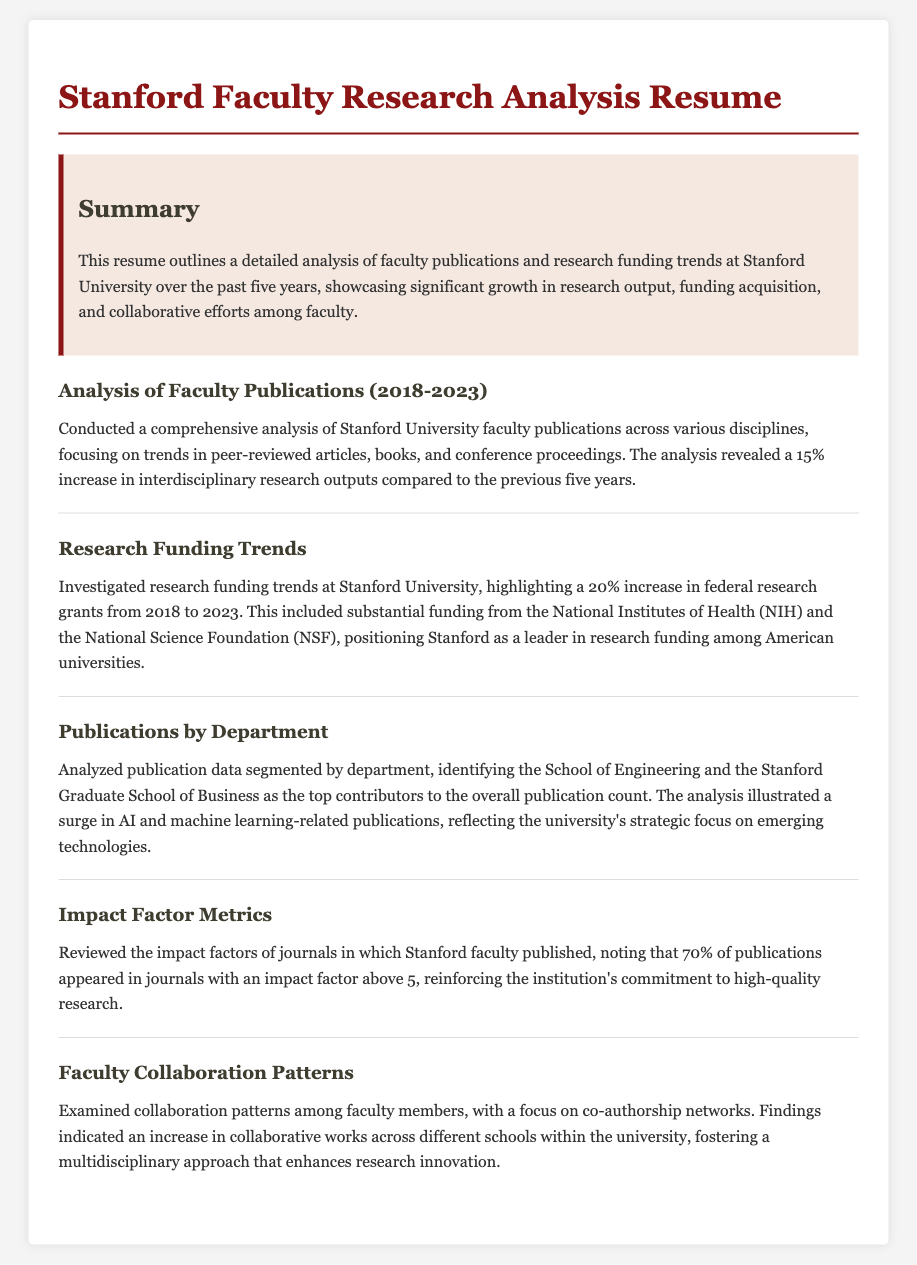What is the increase in interdisciplinary research outputs? The analysis revealed a 15% increase in interdisciplinary research outputs compared to the previous five years.
Answer: 15% What was the percentage increase in federal research grants from 2018 to 2023? Highlighting a 20% increase in federal research grants from 2018 to 2023.
Answer: 20% Which two departments were identified as top contributors to the publication count? The analysis illustrated that the School of Engineering and the Stanford Graduate School of Business were the top contributors.
Answer: School of Engineering and the Stanford Graduate School of Business What percentage of publications appeared in journals with an impact factor above 5? Noting that 70% of publications appeared in journals with an impact factor above 5.
Answer: 70% What major areas saw a surge in publications? The analysis illustrated a surge in AI and machine learning-related publications.
Answer: AI and machine learning What trend was found in faculty collaboration patterns? Findings indicated an increase in collaborative works across different schools within the university.
Answer: Increase in collaborative works What is the focus of the overall analysis presented in the resume? This resume outlines a detailed analysis of faculty publications and research funding trends at Stanford University.
Answer: Faculty publications and research funding trends 